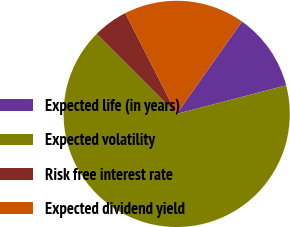Convert chart to OTSL. <chart><loc_0><loc_0><loc_500><loc_500><pie_chart><fcel>Expected life (in years)<fcel>Expected volatility<fcel>Risk free interest rate<fcel>Expected dividend yield<nl><fcel>11.15%<fcel>66.56%<fcel>4.99%<fcel>17.3%<nl></chart> 